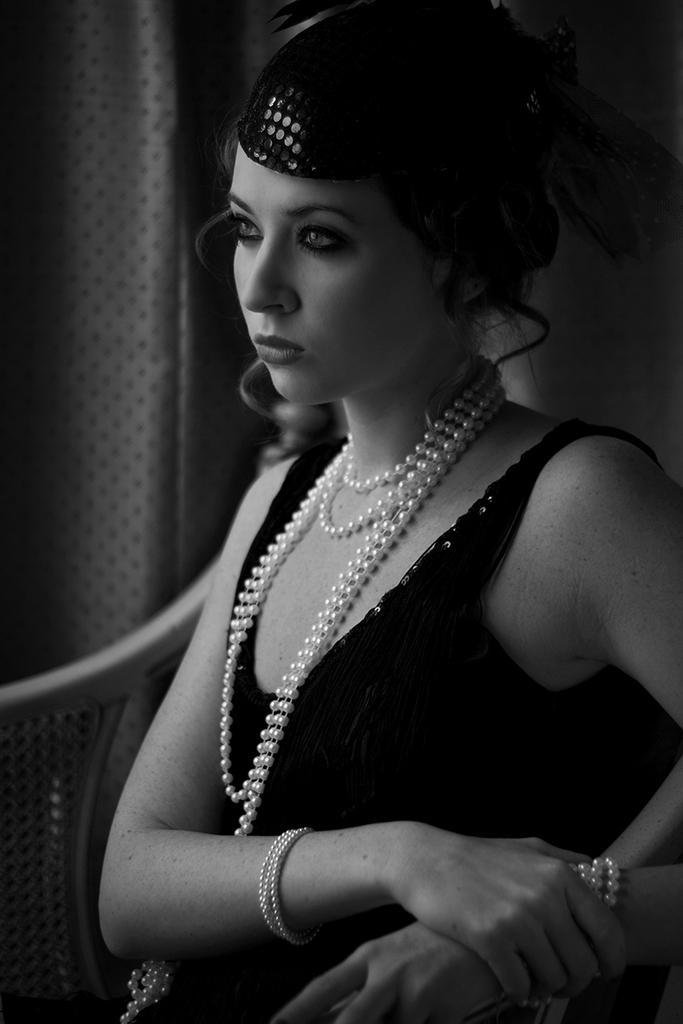Could you give a brief overview of what you see in this image? This is a black and white image of a woman sitting on the chair, and in the background there is a wall. 